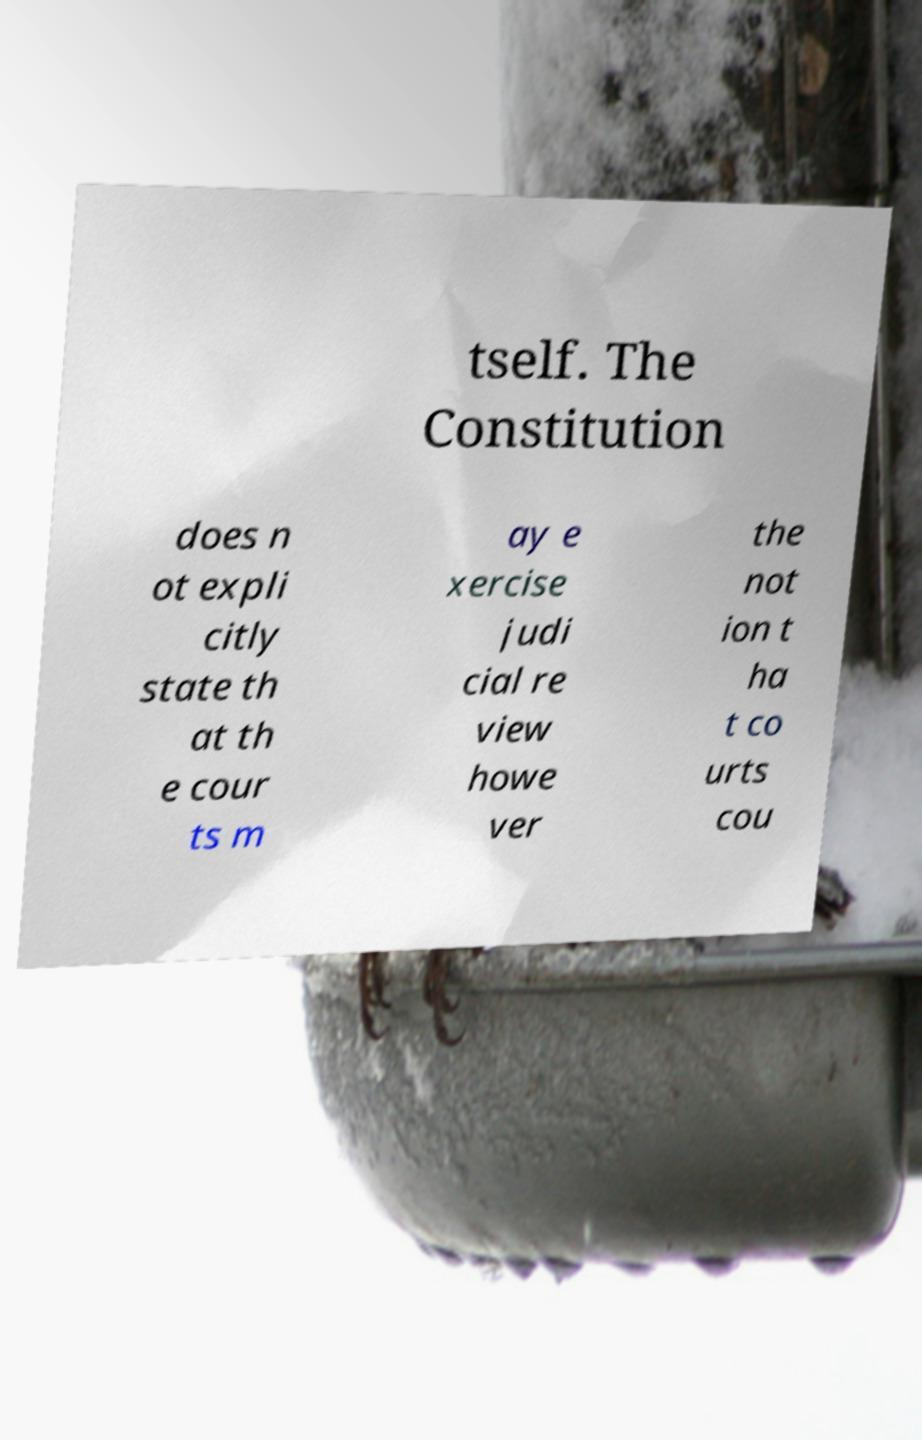Please read and relay the text visible in this image. What does it say? tself. The Constitution does n ot expli citly state th at th e cour ts m ay e xercise judi cial re view howe ver the not ion t ha t co urts cou 